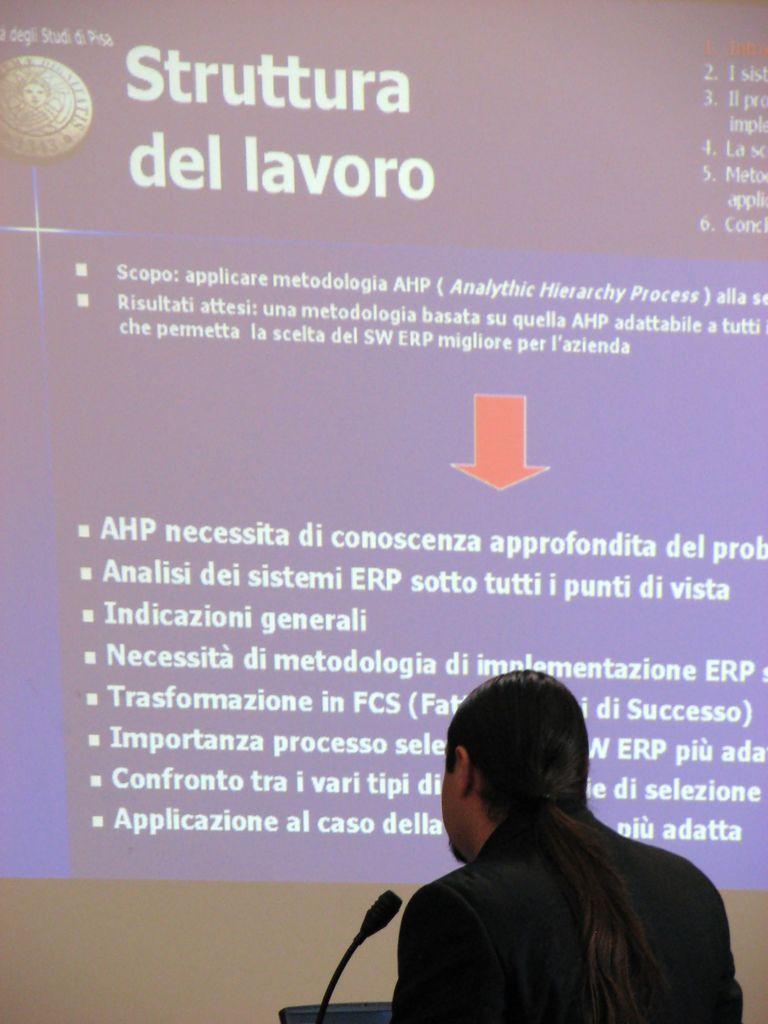In one or two sentences, can you explain what this image depicts? On the right side, there is a person in black color suit, standing in front of a mic which is attached to a stand. In the background, there is a screen having white color texts and red color mark. 